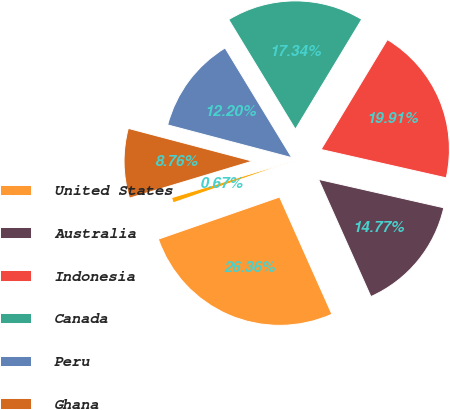Convert chart. <chart><loc_0><loc_0><loc_500><loc_500><pie_chart><fcel>United States<fcel>Australia<fcel>Indonesia<fcel>Canada<fcel>Peru<fcel>Ghana<fcel>Other<nl><fcel>26.36%<fcel>14.77%<fcel>19.91%<fcel>17.34%<fcel>12.2%<fcel>8.76%<fcel>0.67%<nl></chart> 